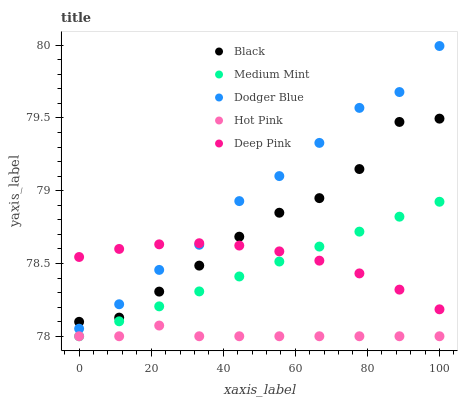Does Hot Pink have the minimum area under the curve?
Answer yes or no. Yes. Does Dodger Blue have the maximum area under the curve?
Answer yes or no. Yes. Does Dodger Blue have the minimum area under the curve?
Answer yes or no. No. Does Hot Pink have the maximum area under the curve?
Answer yes or no. No. Is Medium Mint the smoothest?
Answer yes or no. Yes. Is Dodger Blue the roughest?
Answer yes or no. Yes. Is Hot Pink the smoothest?
Answer yes or no. No. Is Hot Pink the roughest?
Answer yes or no. No. Does Medium Mint have the lowest value?
Answer yes or no. Yes. Does Dodger Blue have the lowest value?
Answer yes or no. No. Does Dodger Blue have the highest value?
Answer yes or no. Yes. Does Hot Pink have the highest value?
Answer yes or no. No. Is Hot Pink less than Dodger Blue?
Answer yes or no. Yes. Is Dodger Blue greater than Medium Mint?
Answer yes or no. Yes. Does Hot Pink intersect Medium Mint?
Answer yes or no. Yes. Is Hot Pink less than Medium Mint?
Answer yes or no. No. Is Hot Pink greater than Medium Mint?
Answer yes or no. No. Does Hot Pink intersect Dodger Blue?
Answer yes or no. No. 